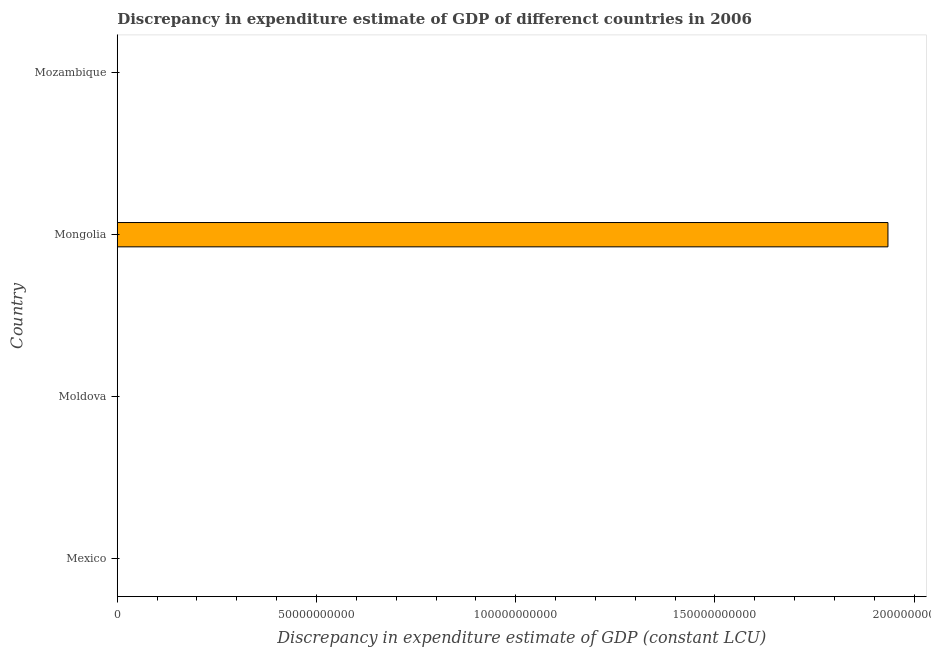Does the graph contain grids?
Give a very brief answer. No. What is the title of the graph?
Your answer should be very brief. Discrepancy in expenditure estimate of GDP of differenct countries in 2006. What is the label or title of the X-axis?
Your answer should be compact. Discrepancy in expenditure estimate of GDP (constant LCU). What is the discrepancy in expenditure estimate of gdp in Mongolia?
Keep it short and to the point. 1.93e+11. Across all countries, what is the maximum discrepancy in expenditure estimate of gdp?
Your response must be concise. 1.93e+11. Across all countries, what is the minimum discrepancy in expenditure estimate of gdp?
Give a very brief answer. 0. In which country was the discrepancy in expenditure estimate of gdp maximum?
Give a very brief answer. Mongolia. What is the sum of the discrepancy in expenditure estimate of gdp?
Your response must be concise. 1.93e+11. What is the difference between the discrepancy in expenditure estimate of gdp in Moldova and Mongolia?
Make the answer very short. -1.93e+11. What is the average discrepancy in expenditure estimate of gdp per country?
Offer a terse response. 4.84e+1. What is the median discrepancy in expenditure estimate of gdp?
Keep it short and to the point. 3.57e+05. What is the difference between the highest and the lowest discrepancy in expenditure estimate of gdp?
Give a very brief answer. 1.93e+11. In how many countries, is the discrepancy in expenditure estimate of gdp greater than the average discrepancy in expenditure estimate of gdp taken over all countries?
Keep it short and to the point. 1. How many bars are there?
Your response must be concise. 2. How many countries are there in the graph?
Your response must be concise. 4. What is the difference between two consecutive major ticks on the X-axis?
Give a very brief answer. 5.00e+1. Are the values on the major ticks of X-axis written in scientific E-notation?
Offer a terse response. No. What is the Discrepancy in expenditure estimate of GDP (constant LCU) in Mexico?
Offer a terse response. 0. What is the Discrepancy in expenditure estimate of GDP (constant LCU) of Moldova?
Make the answer very short. 7.14e+05. What is the Discrepancy in expenditure estimate of GDP (constant LCU) in Mongolia?
Your response must be concise. 1.93e+11. What is the difference between the Discrepancy in expenditure estimate of GDP (constant LCU) in Moldova and Mongolia?
Ensure brevity in your answer.  -1.93e+11. 